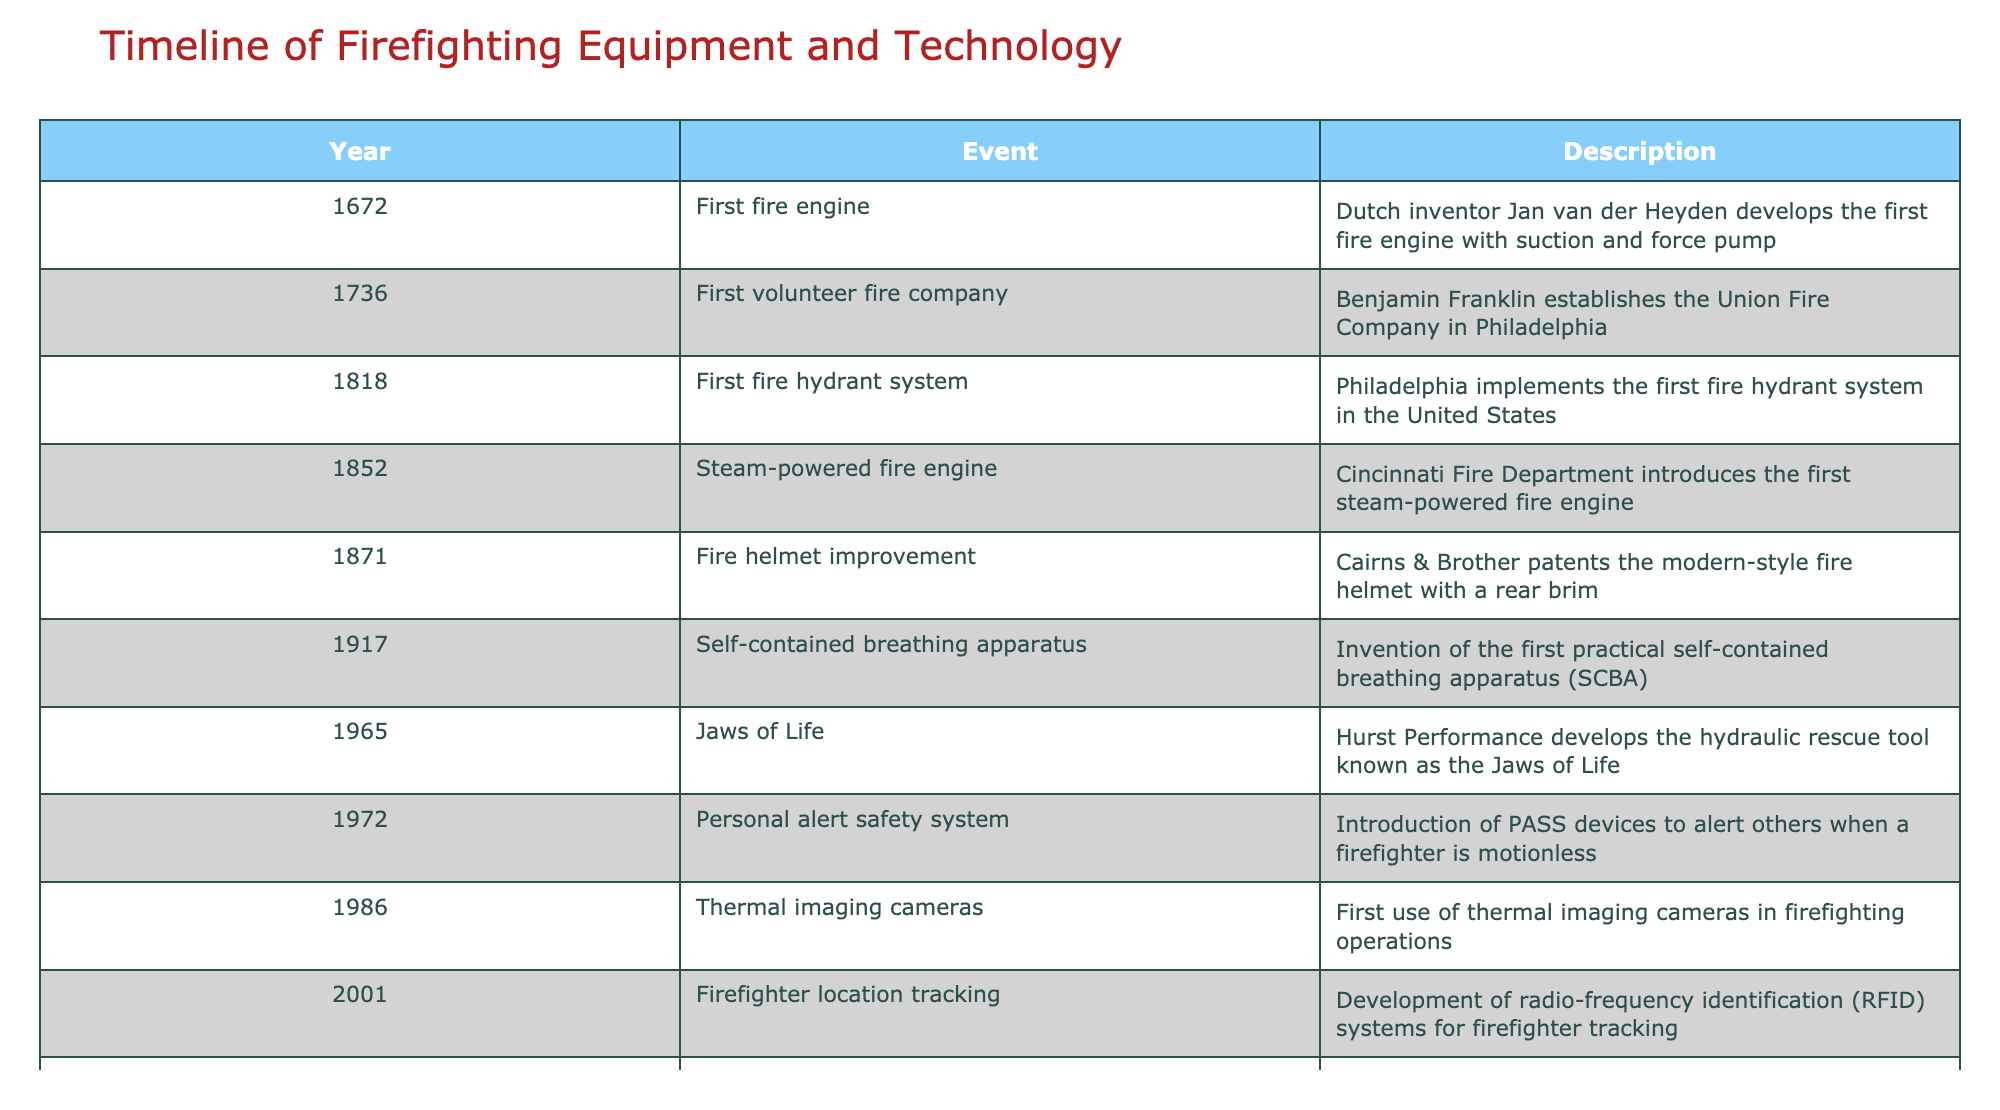What year was the first fire engine developed? The table lists multiple events along with their corresponding years. The row indicating the first fire engine developed by Jan van der Heyden states the year as 1672.
Answer: 1672 Who established the first volunteer fire company? Looking at the table, the entry for the year 1736 indicates that Benjamin Franklin established the Union Fire Company in Philadelphia.
Answer: Benjamin Franklin What event marks the introduction of the first steam-powered fire engine? The table indicates that the first steam-powered fire engine was introduced by the Cincinnati Fire Department in the year 1852.
Answer: 1852 Is the introduction of the first personal alert safety system listed in the table? Reviewing the table, there is indeed an entry for the year 1972, which mentions the introduction of PASS devices for alerting when a firefighter is motionless. Therefore, the answer is yes.
Answer: Yes How many years passed between the development of the first fire hydrant system and the introduction of thermal imaging cameras? The first fire hydrant system was implemented in 1818, and thermal imaging cameras were first used in 1986. Calculating the difference involves subtracting 1818 from 1986, resulting in 1986 - 1818 = 168 years.
Answer: 168 years What was the significant change in firefighting technology introduced in 2015? The table details that in 2015, smart firefighting was introduced, utilizing IoT sensors and AI for enhanced real-time fire prediction and response.
Answer: Smart firefighting What technological advancement took place in 1965, and who developed it? According to the table, the Jaws of Life, which is a hydraulic rescue tool, was developed by Hurst Performance in 1965.
Answer: Jaws of Life by Hurst Performance Which two events occurred in the 2000s related to firefighting technologies, and what were they? Examining the table, the two events that took place in the 2000s are the development of RFID systems for firefighter tracking in 2001 and the integration of drones for aerial reconnaissance in 2010.
Answer: RFID systems in 2001 and drone technology in 2010 How many significant technological advancements were made before 1900? By reviewing the table, the events that occurred prior to 1900 are the first fire engine (1672), the first volunteer fire company (1736), the first fire hydrant system (1818), the steam-powered fire engine (1852), and the fire helmet improvement (1871). Counting these gives us a total of 5 advancements.
Answer: 5 